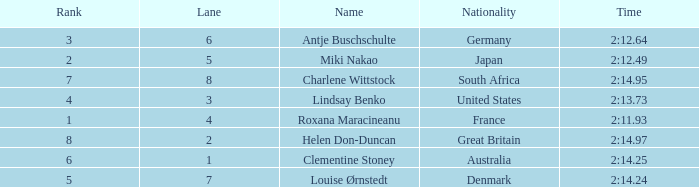What is the average Rank for a lane smaller than 3 with a nationality of Australia? 6.0. 